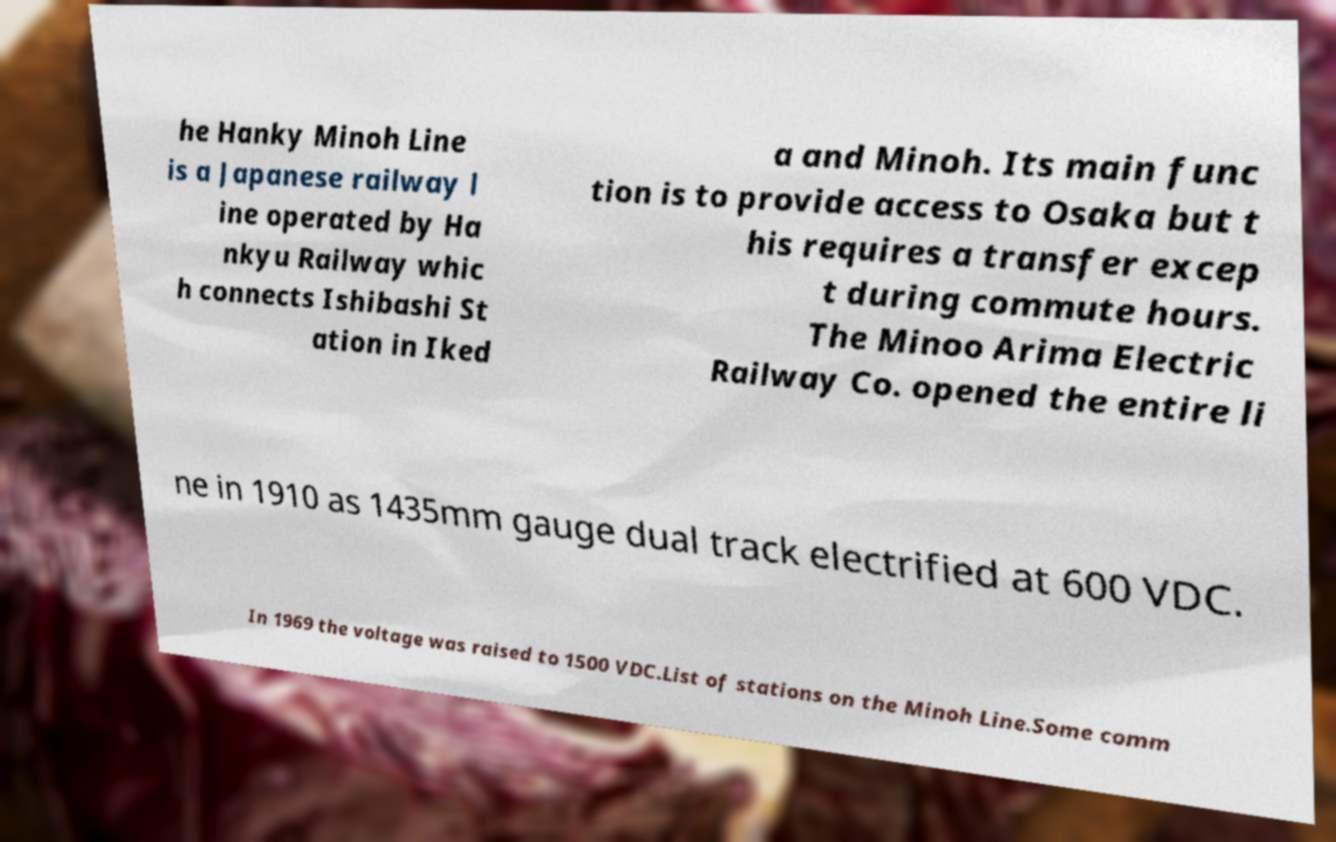Could you assist in decoding the text presented in this image and type it out clearly? he Hanky Minoh Line is a Japanese railway l ine operated by Ha nkyu Railway whic h connects Ishibashi St ation in Iked a and Minoh. Its main func tion is to provide access to Osaka but t his requires a transfer excep t during commute hours. The Minoo Arima Electric Railway Co. opened the entire li ne in 1910 as 1435mm gauge dual track electrified at 600 VDC. In 1969 the voltage was raised to 1500 VDC.List of stations on the Minoh Line.Some comm 